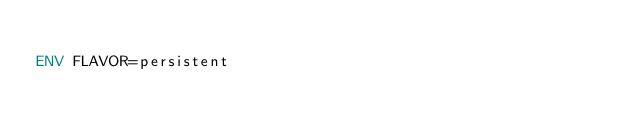<code> <loc_0><loc_0><loc_500><loc_500><_Dockerfile_>
ENV FLAVOR=persistent
</code> 